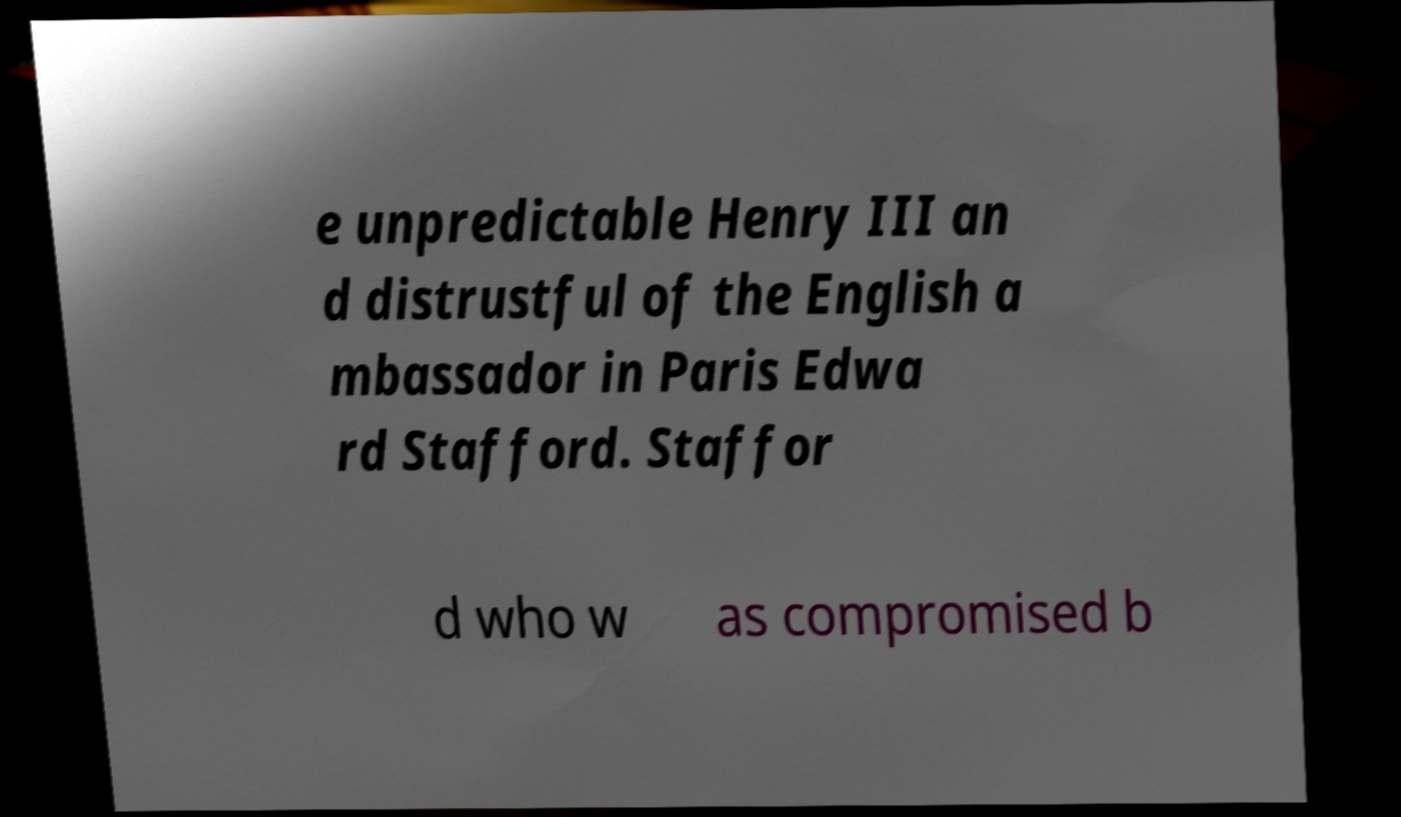There's text embedded in this image that I need extracted. Can you transcribe it verbatim? e unpredictable Henry III an d distrustful of the English a mbassador in Paris Edwa rd Stafford. Staffor d who w as compromised b 